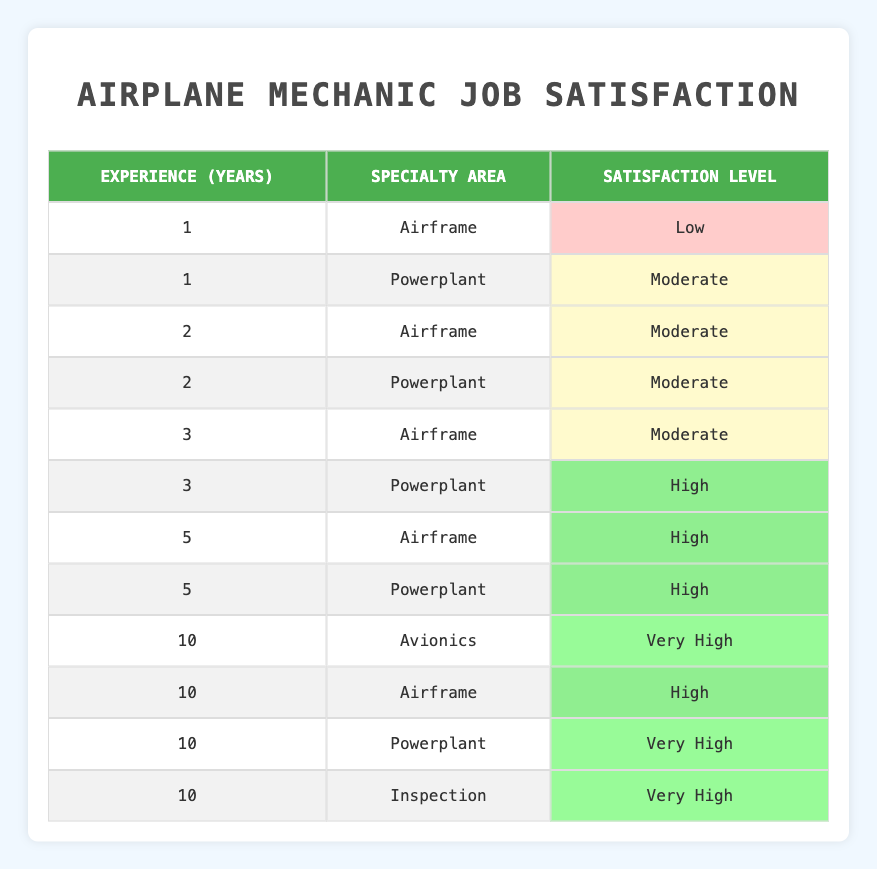What is the job satisfaction level for airplane mechanics with 1 year of experience in Airframe? According to the table, there is only one entry for airplane mechanics with 1 year of experience in the Airframe specialty area, which indicates a satisfaction level of Low.
Answer: Low How many mechanics have a satisfaction level of High? The table shows that there are three mechanics with a High satisfaction level: one with 3 years of experience in Powerplant, and two with 5 years of experience (one in Airframe and one in Powerplant).
Answer: 3 True or False: All mechanics with 10 years of experience have a satisfaction level of Very High. In the table, there are four mechanics with 10 years of experience, two of whom have a satisfaction level of Very High (in Avionics and Powerplant), but the mechanic in Airframe has a satisfaction level of High. Therefore, it's false that all have Very High satisfaction.
Answer: False What is the most common satisfaction level for mechanics with 2 years of experience? There are two mechanics with 2 years of experience, both in different specialties (Airframe and Powerplant), and both report a satisfaction level of Moderate. Therefore, the most common satisfaction level for this group is Moderate.
Answer: Moderate What percentage of mechanics with 10 years of experience report a satisfaction level of Very High? There are four mechanics with 10 years of experience. Two of them (Avionics and Powerplant) report a satisfaction level of Very High. To find the percentage, divide the number of Very High reports (2) by the total number of mechanics (4) and multiply by 100: (2/4) * 100 = 50%.
Answer: 50% 